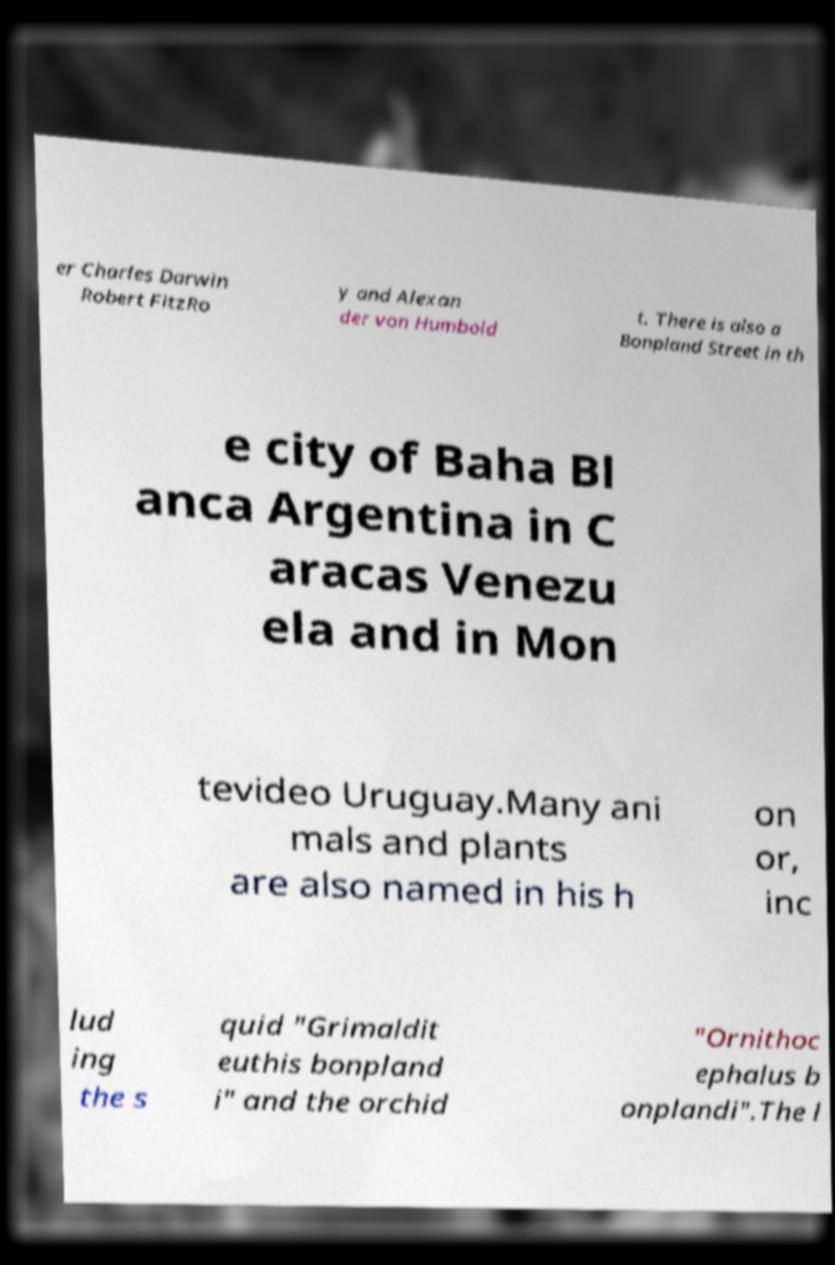Could you extract and type out the text from this image? er Charles Darwin Robert FitzRo y and Alexan der von Humbold t. There is also a Bonpland Street in th e city of Baha Bl anca Argentina in C aracas Venezu ela and in Mon tevideo Uruguay.Many ani mals and plants are also named in his h on or, inc lud ing the s quid "Grimaldit euthis bonpland i" and the orchid "Ornithoc ephalus b onplandi".The l 